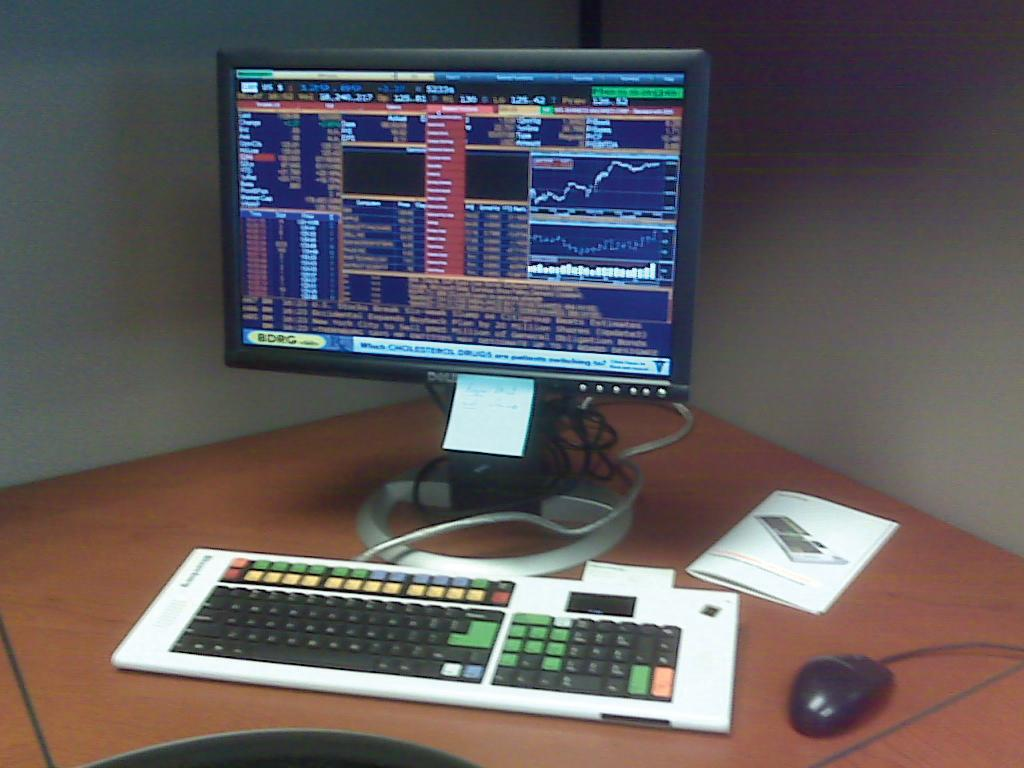What type of electronic device is visible in the image? There is a monitor in the image. What is used for input with the monitor? There is a keyboard and a mouse in the image. Are there any cords or cables visible in the image? Yes, there are cables in the image. What other object can be seen on the table in the image? There is a book on the table in the image. What is visible in the background of the image? There is a wall in the background of the image. What type of scale can be seen in the image? There is no scale present in the image. What color is the shirt worn by the person in the image? There is no person or shirt visible in the image. 